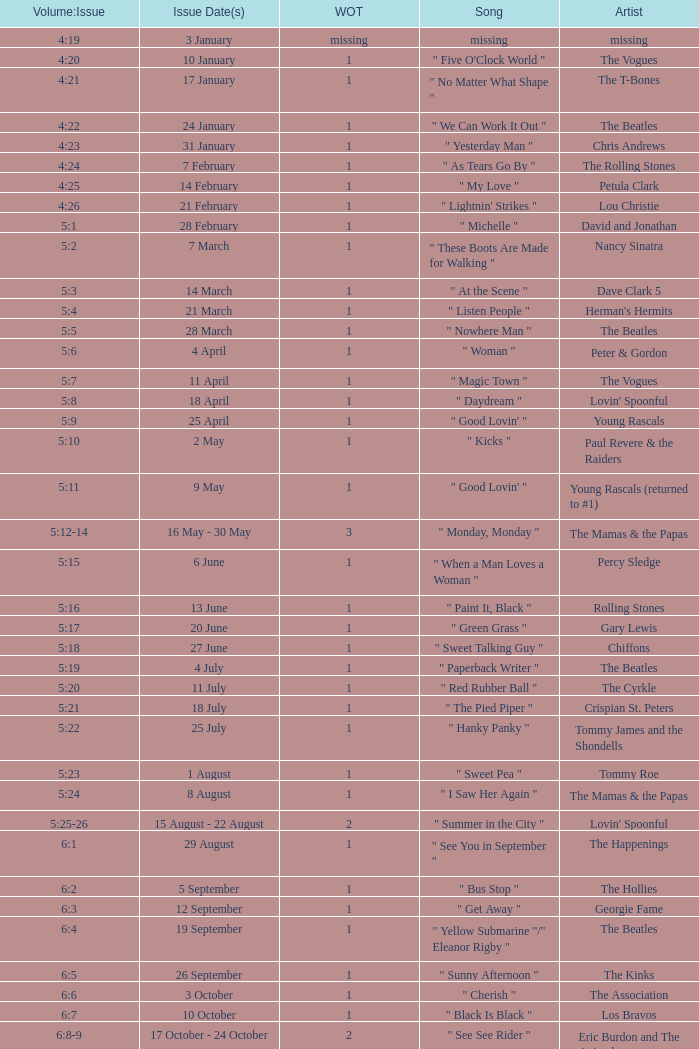Volume:Issue of 5:16 has what song listed? " Paint It, Black ". 